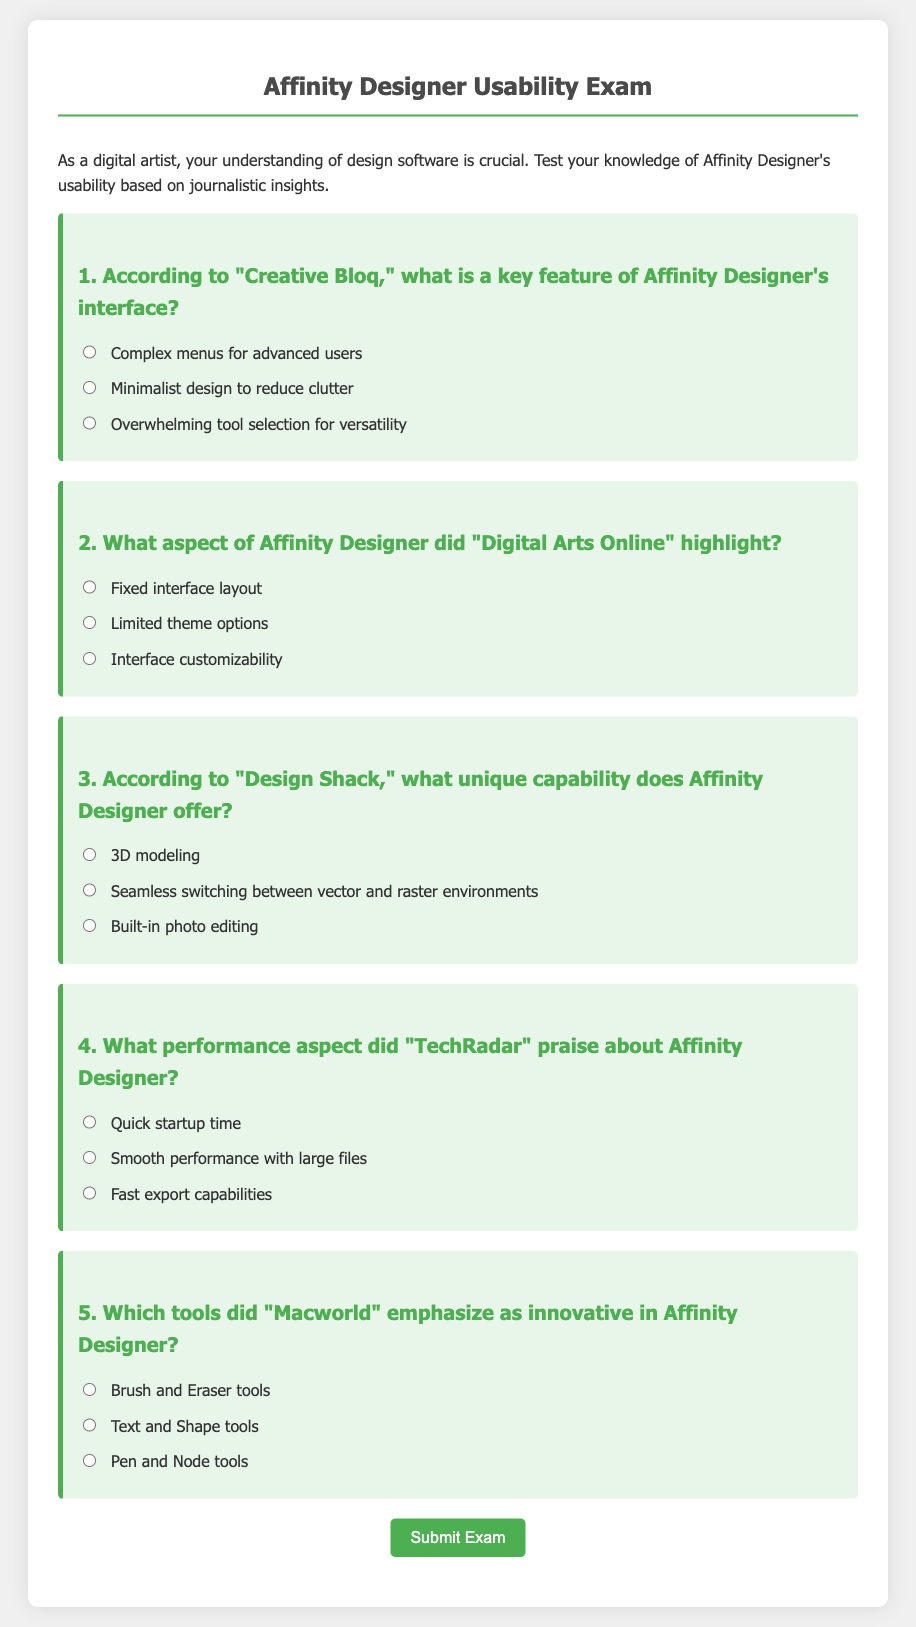What is the title of the document? The title of the document is stated in the `<title>` tag section of the code, which is "Affinity Designer Usability Exam."
Answer: Affinity Designer Usability Exam Who is the intended audience of the exam? The intended audience is described in the introductory paragraph, noting that it is for digital artists to test their knowledge.
Answer: Digital artists What is the first question in the exam? The first question is found in the form's HTML structure, which asks about a key feature of Affinity Designer's interface according to "Creative Bloq."
Answer: According to "Creative Bloq," what is a key feature of Affinity Designer's interface? Which website is mentioned to highlight the interface customizability? The question about interface customizability specifically cites "Digital Arts Online" within the exam's content.
Answer: Digital Arts Online What performance aspect is praised by "TechRadar"? The relevant question indicating what is praised by "TechRadar" deals with smooth performance with large files as highlighted in the document.
Answer: Smooth performance with large files What color is used for the question background in the exam? The CSS associated with the questions in the document defines the background color as light green (#e8f5e9).
Answer: Light green How many questions are included in the exam? The total number of questions can be counted in the form structure which lists five separate questions within the document.
Answer: Five 